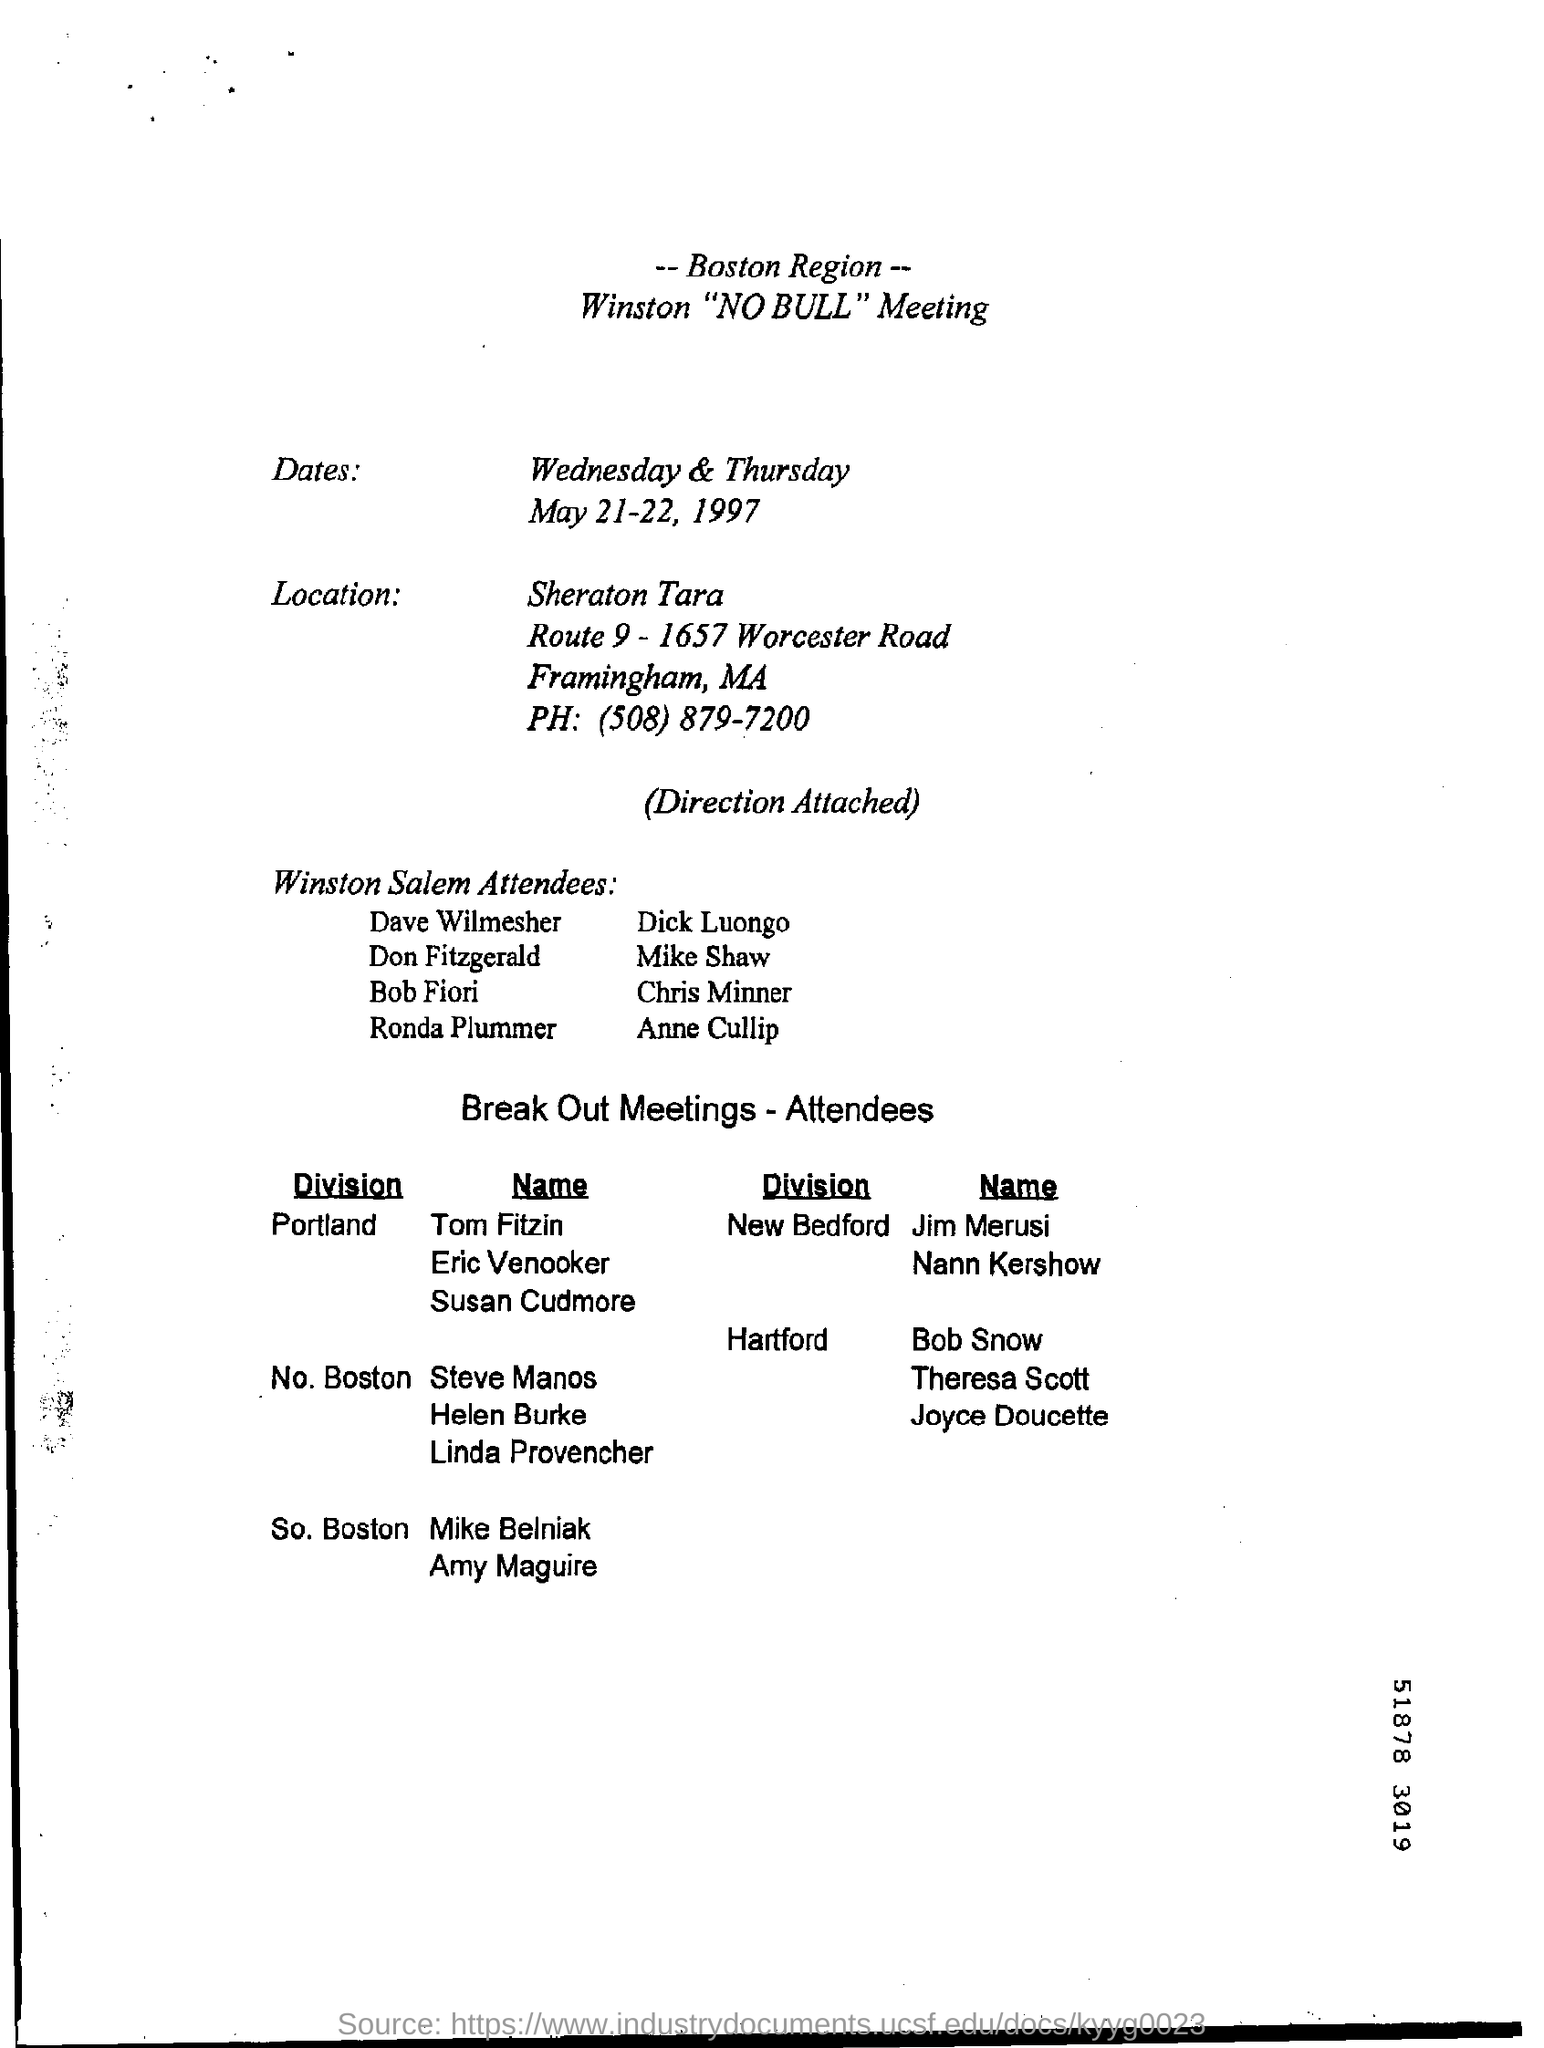What is the title of the meeting?
Your response must be concise. Winston "NO BULL" Meeting. 